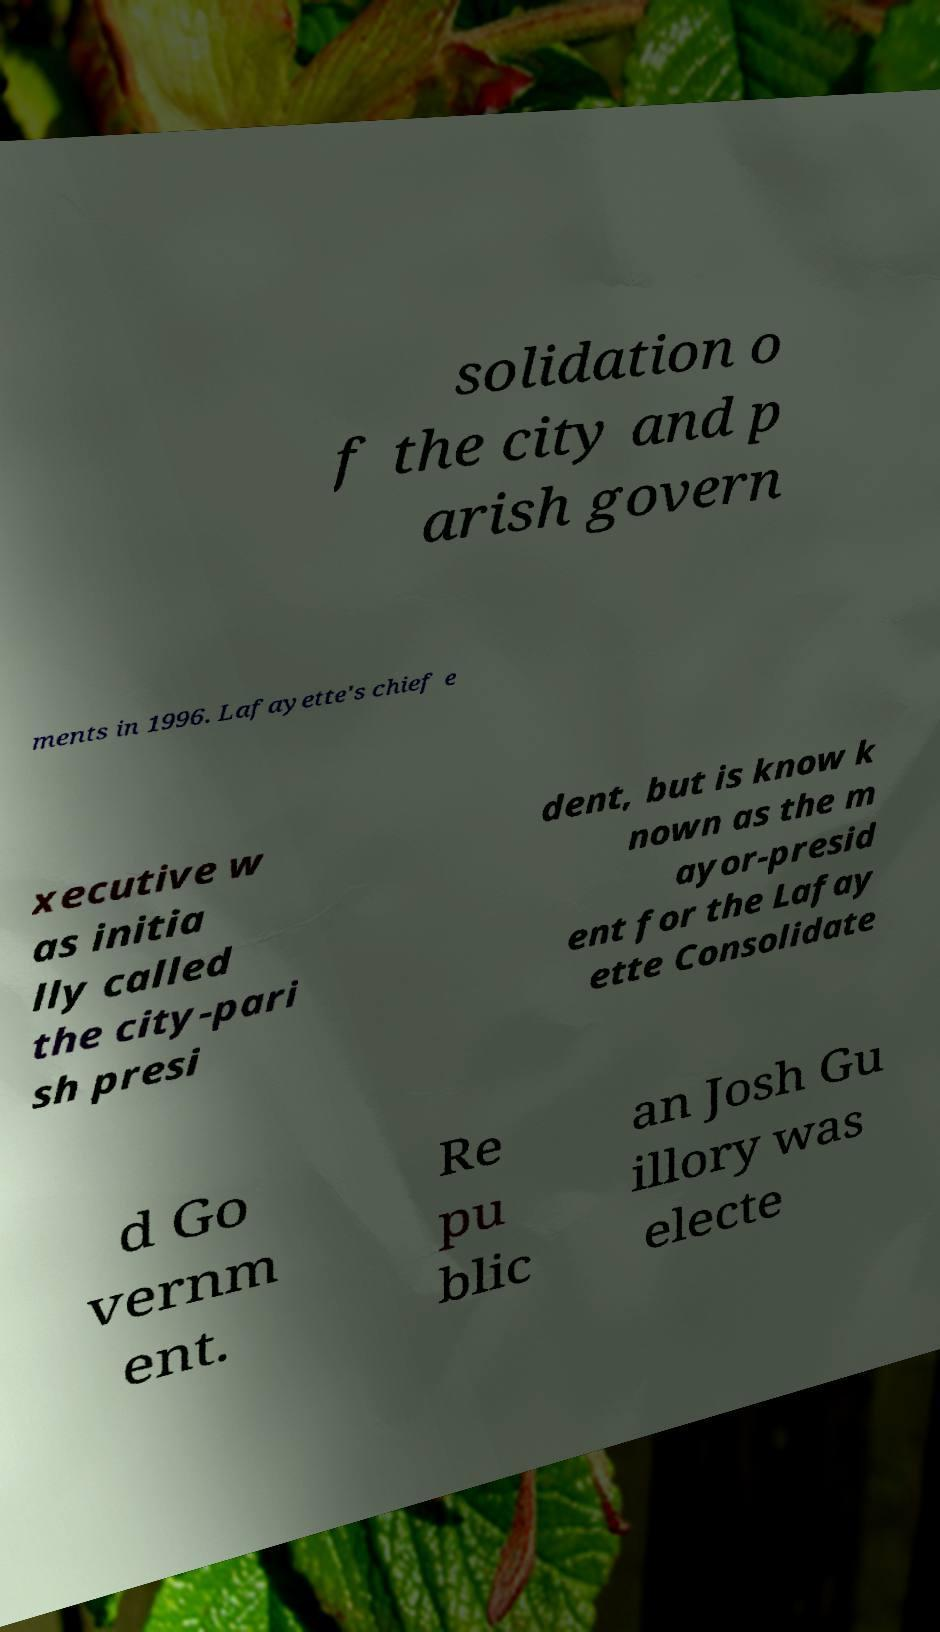Please identify and transcribe the text found in this image. solidation o f the city and p arish govern ments in 1996. Lafayette's chief e xecutive w as initia lly called the city-pari sh presi dent, but is know k nown as the m ayor-presid ent for the Lafay ette Consolidate d Go vernm ent. Re pu blic an Josh Gu illory was electe 